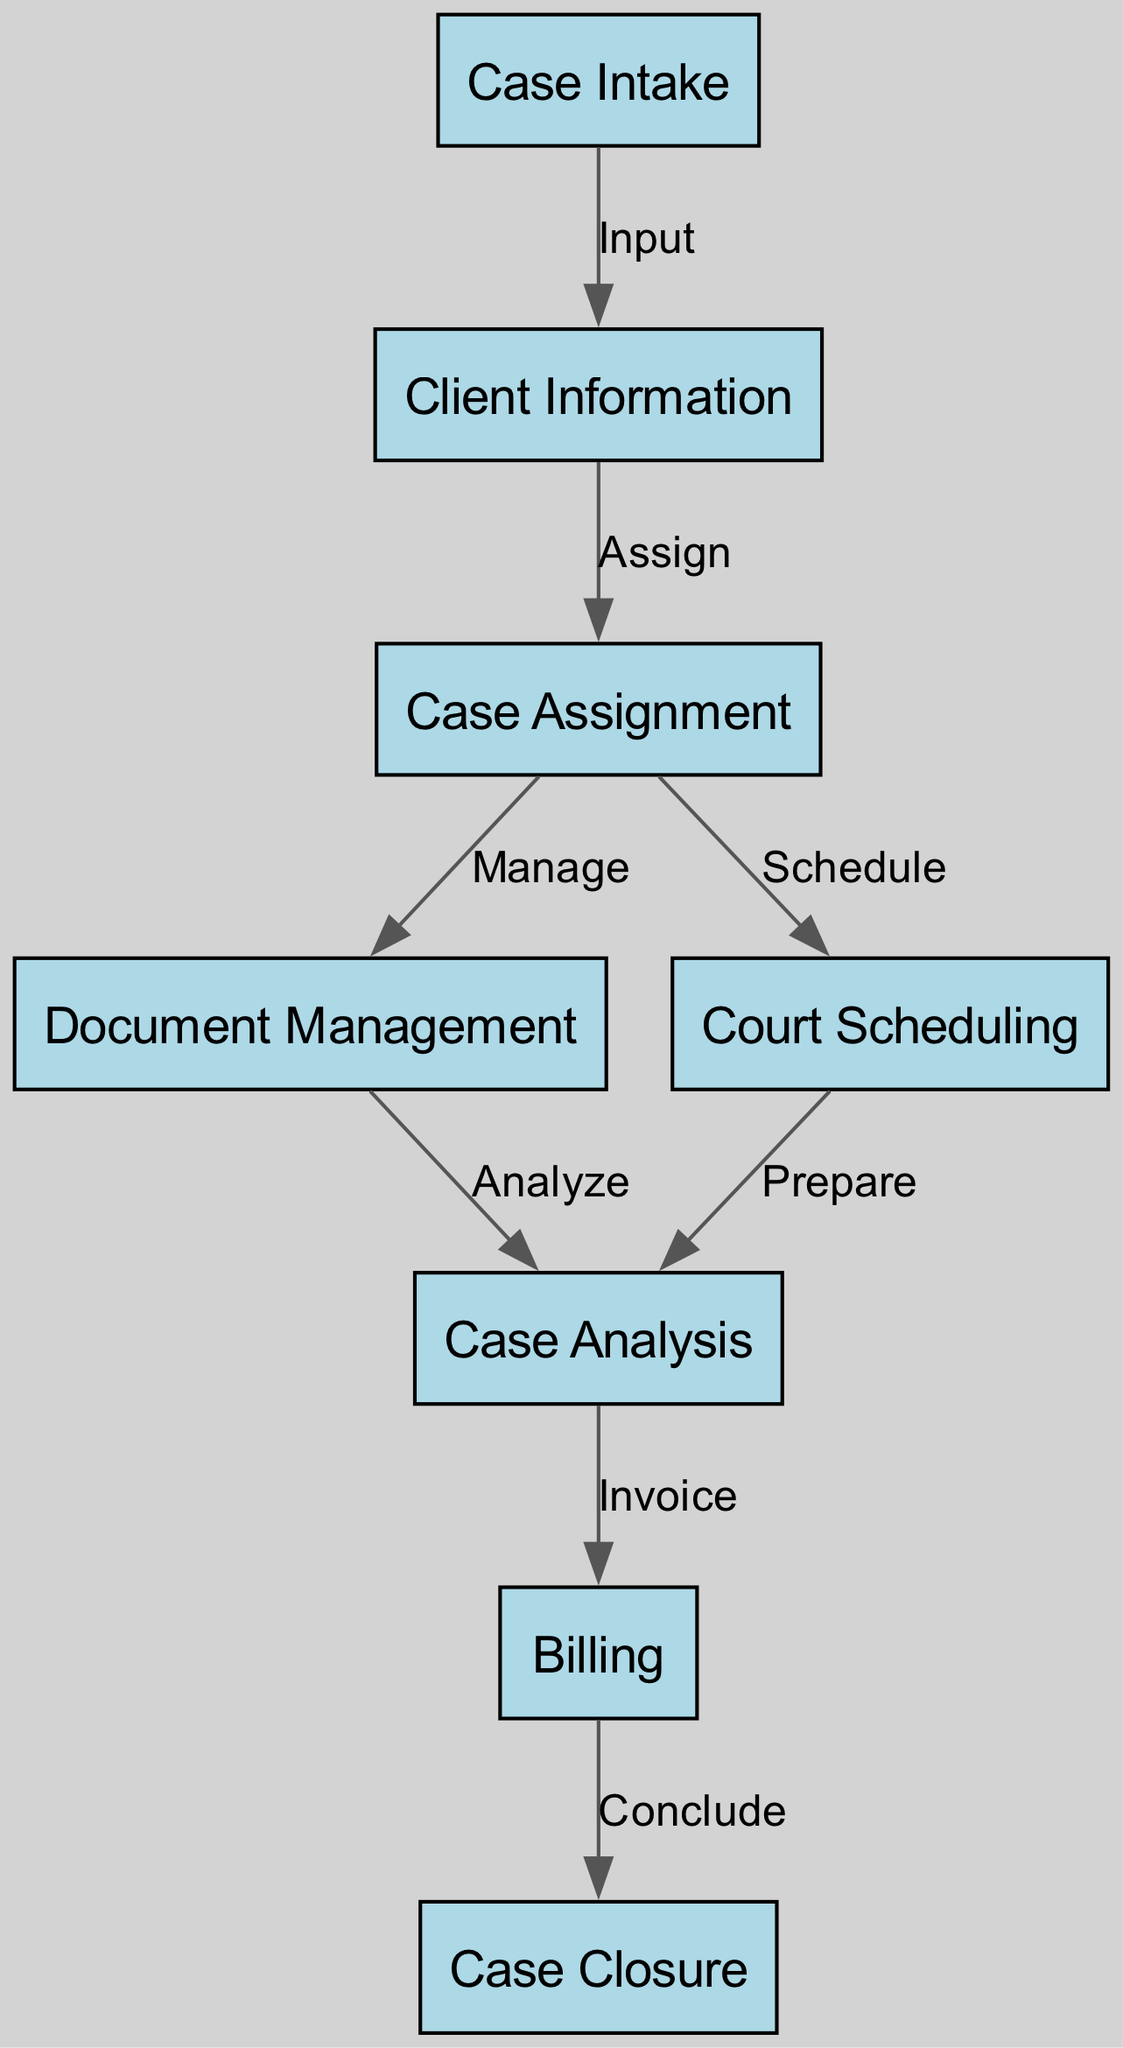What is the first step in the process flow diagram? The first step is represented by the node "Case Intake." This is identified as the initial node in the diagram, which begins the sequence of events.
Answer: Case Intake How many nodes are present in the diagram? By counting the nodes listed in the data, there are eight distinct nodes in total. Each node corresponds to a specific step in the legal case management system.
Answer: 8 What action follows "Client Information"? The action that follows "Client Information" is labeled as "Assign," as indicated by the directed edge connecting these two nodes in the flow.
Answer: Assign Which node is immediately before "Case Closure"? "Billing" is the node immediately before "Case Closure," as evidenced by the edge leading from "Billing" to "Case Closure."
Answer: Billing What is the relationship between "Document Management" and "Case Analysis"? The relationship is described by the edge labeled "Analyze," indicating that document management feeds into the case analysis stage during the process flow.
Answer: Analyze How many edges are there in the diagram? There are a total of seven edges, which connect the various nodes and represent the flow of actions within the case management process.
Answer: 7 Which node connects to both "Case Assignment" and "Court Scheduling"? "Case Assignment" connects to both "Document Management" and "Court Scheduling," with edges indicating "Manage" and "Schedule," respectively.
Answer: Case Assignment What is the last action completed in the process? The last action is labeled "Conclude," which connects from "Billing" to "Case Closure," indicating the final step in the workflow.
Answer: Conclude What is the primary focus of the flow starting from "Case Analysis"? The primary focus after "Case Analysis" is on billing activities, specifically leading to the action labeled "Invoice," which indicates a financial step following analysis.
Answer: Invoice 